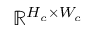<formula> <loc_0><loc_0><loc_500><loc_500>\mathbb { R } ^ { H _ { c } \times W _ { c } }</formula> 